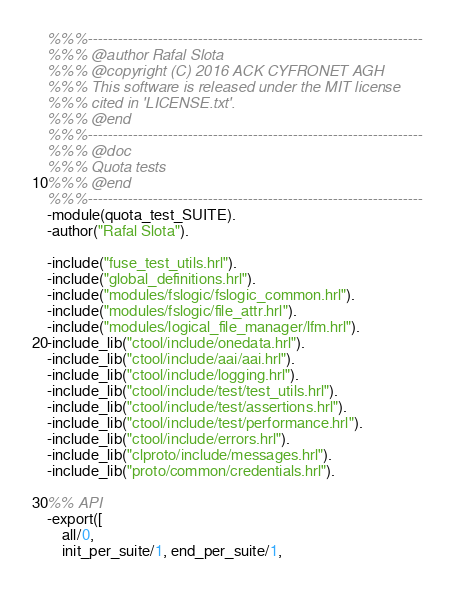<code> <loc_0><loc_0><loc_500><loc_500><_Erlang_>%%%-------------------------------------------------------------------
%%% @author Rafal Slota
%%% @copyright (C) 2016 ACK CYFRONET AGH
%%% This software is released under the MIT license
%%% cited in 'LICENSE.txt'.
%%% @end
%%%-------------------------------------------------------------------
%%% @doc
%%% Quota tests
%%% @end
%%%-------------------------------------------------------------------
-module(quota_test_SUITE).
-author("Rafal Slota").

-include("fuse_test_utils.hrl").
-include("global_definitions.hrl").
-include("modules/fslogic/fslogic_common.hrl").
-include("modules/fslogic/file_attr.hrl").
-include("modules/logical_file_manager/lfm.hrl").
-include_lib("ctool/include/onedata.hrl").
-include_lib("ctool/include/aai/aai.hrl").
-include_lib("ctool/include/logging.hrl").
-include_lib("ctool/include/test/test_utils.hrl").
-include_lib("ctool/include/test/assertions.hrl").
-include_lib("ctool/include/test/performance.hrl").
-include_lib("ctool/include/errors.hrl").
-include_lib("clproto/include/messages.hrl").
-include_lib("proto/common/credentials.hrl").

%% API
-export([
    all/0,
    init_per_suite/1, end_per_suite/1,</code> 